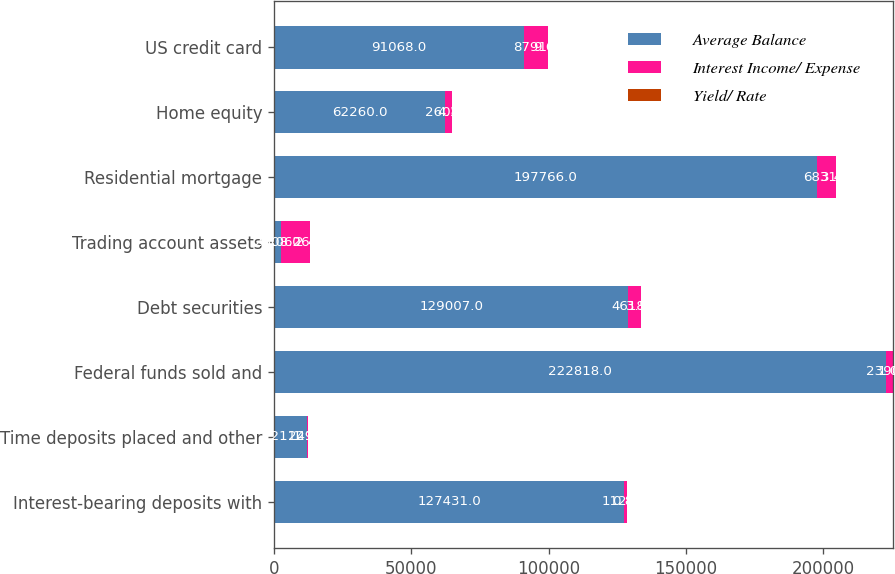<chart> <loc_0><loc_0><loc_500><loc_500><stacked_bar_chart><ecel><fcel>Interest-bearing deposits with<fcel>Time deposits placed and other<fcel>Federal funds sold and<fcel>Debt securities<fcel>Trading account assets<fcel>Residential mortgage<fcel>Home equity<fcel>US credit card<nl><fcel>Average Balance<fcel>127431<fcel>12112<fcel>222818<fcel>129007<fcel>2608<fcel>197766<fcel>62260<fcel>91068<nl><fcel>Interest Income/ Expense<fcel>1122<fcel>241<fcel>2390<fcel>4618<fcel>10626<fcel>6831<fcel>2608<fcel>8791<nl><fcel>Yield/ Rate<fcel>0.88<fcel>1.99<fcel>1.07<fcel>3.58<fcel>2.44<fcel>3.45<fcel>4.19<fcel>9.65<nl></chart> 